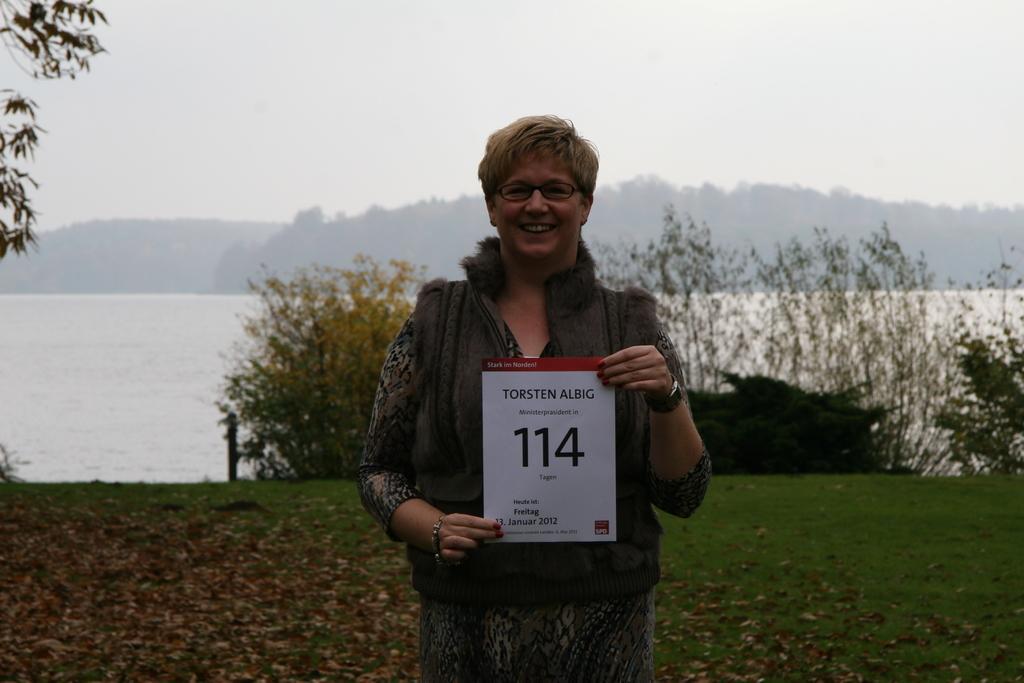In one or two sentences, can you explain what this image depicts? This picture is clicked outside the city. In the center there is a person holding a paper, smiling and standing on the ground and we can see the text and the numbers printed on the paper. In the background we can see the sky, trees, plants, grass and a water body. 